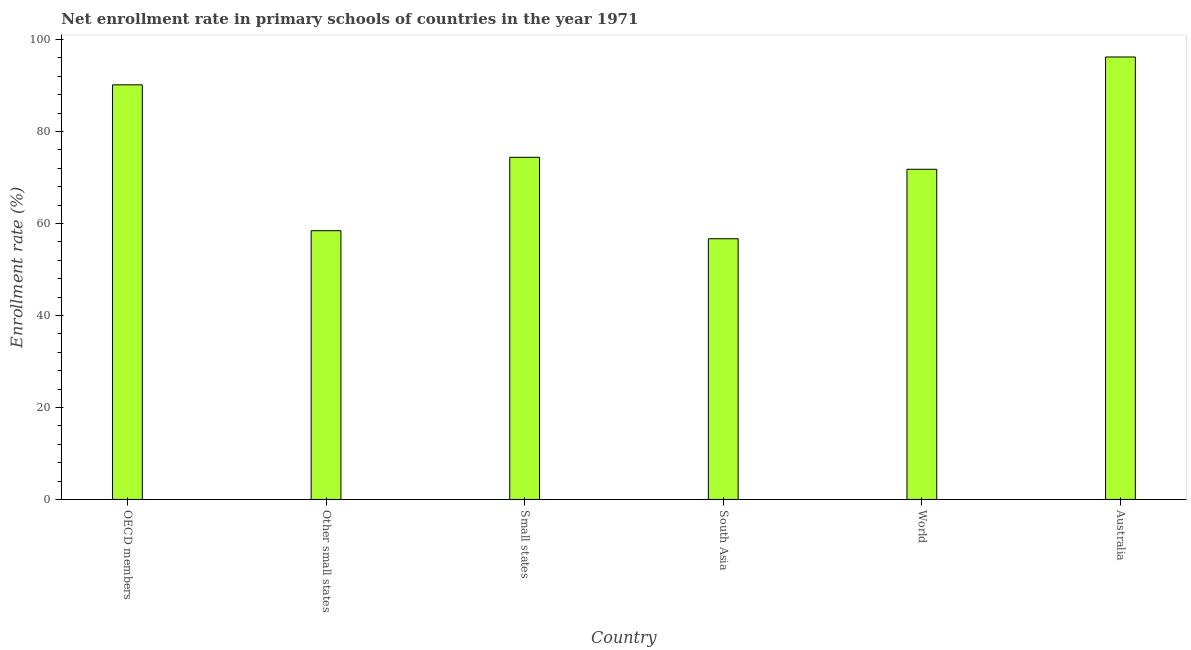Does the graph contain any zero values?
Your answer should be very brief. No. What is the title of the graph?
Ensure brevity in your answer.  Net enrollment rate in primary schools of countries in the year 1971. What is the label or title of the Y-axis?
Provide a succinct answer. Enrollment rate (%). What is the net enrollment rate in primary schools in World?
Ensure brevity in your answer.  71.79. Across all countries, what is the maximum net enrollment rate in primary schools?
Offer a terse response. 96.2. Across all countries, what is the minimum net enrollment rate in primary schools?
Keep it short and to the point. 56.69. In which country was the net enrollment rate in primary schools maximum?
Ensure brevity in your answer.  Australia. In which country was the net enrollment rate in primary schools minimum?
Give a very brief answer. South Asia. What is the sum of the net enrollment rate in primary schools?
Your response must be concise. 447.65. What is the difference between the net enrollment rate in primary schools in South Asia and World?
Your answer should be compact. -15.1. What is the average net enrollment rate in primary schools per country?
Provide a short and direct response. 74.61. What is the median net enrollment rate in primary schools?
Provide a succinct answer. 73.09. In how many countries, is the net enrollment rate in primary schools greater than 20 %?
Offer a terse response. 6. What is the ratio of the net enrollment rate in primary schools in OECD members to that in South Asia?
Ensure brevity in your answer.  1.59. What is the difference between the highest and the second highest net enrollment rate in primary schools?
Your answer should be very brief. 6.05. Is the sum of the net enrollment rate in primary schools in OECD members and World greater than the maximum net enrollment rate in primary schools across all countries?
Provide a short and direct response. Yes. What is the difference between the highest and the lowest net enrollment rate in primary schools?
Offer a very short reply. 39.51. How many bars are there?
Your response must be concise. 6. Are all the bars in the graph horizontal?
Keep it short and to the point. No. What is the Enrollment rate (%) in OECD members?
Provide a succinct answer. 90.15. What is the Enrollment rate (%) of Other small states?
Ensure brevity in your answer.  58.44. What is the Enrollment rate (%) of Small states?
Your answer should be very brief. 74.39. What is the Enrollment rate (%) in South Asia?
Offer a terse response. 56.69. What is the Enrollment rate (%) in World?
Provide a succinct answer. 71.79. What is the Enrollment rate (%) in Australia?
Make the answer very short. 96.2. What is the difference between the Enrollment rate (%) in OECD members and Other small states?
Provide a succinct answer. 31.71. What is the difference between the Enrollment rate (%) in OECD members and Small states?
Your answer should be compact. 15.76. What is the difference between the Enrollment rate (%) in OECD members and South Asia?
Provide a succinct answer. 33.46. What is the difference between the Enrollment rate (%) in OECD members and World?
Ensure brevity in your answer.  18.36. What is the difference between the Enrollment rate (%) in OECD members and Australia?
Your answer should be compact. -6.05. What is the difference between the Enrollment rate (%) in Other small states and Small states?
Offer a terse response. -15.95. What is the difference between the Enrollment rate (%) in Other small states and South Asia?
Provide a short and direct response. 1.75. What is the difference between the Enrollment rate (%) in Other small states and World?
Make the answer very short. -13.35. What is the difference between the Enrollment rate (%) in Other small states and Australia?
Ensure brevity in your answer.  -37.76. What is the difference between the Enrollment rate (%) in Small states and South Asia?
Make the answer very short. 17.7. What is the difference between the Enrollment rate (%) in Small states and World?
Your response must be concise. 2.6. What is the difference between the Enrollment rate (%) in Small states and Australia?
Offer a very short reply. -21.81. What is the difference between the Enrollment rate (%) in South Asia and World?
Make the answer very short. -15.1. What is the difference between the Enrollment rate (%) in South Asia and Australia?
Your answer should be very brief. -39.51. What is the difference between the Enrollment rate (%) in World and Australia?
Your answer should be compact. -24.41. What is the ratio of the Enrollment rate (%) in OECD members to that in Other small states?
Provide a succinct answer. 1.54. What is the ratio of the Enrollment rate (%) in OECD members to that in Small states?
Make the answer very short. 1.21. What is the ratio of the Enrollment rate (%) in OECD members to that in South Asia?
Make the answer very short. 1.59. What is the ratio of the Enrollment rate (%) in OECD members to that in World?
Offer a very short reply. 1.26. What is the ratio of the Enrollment rate (%) in OECD members to that in Australia?
Provide a short and direct response. 0.94. What is the ratio of the Enrollment rate (%) in Other small states to that in Small states?
Make the answer very short. 0.79. What is the ratio of the Enrollment rate (%) in Other small states to that in South Asia?
Offer a very short reply. 1.03. What is the ratio of the Enrollment rate (%) in Other small states to that in World?
Offer a terse response. 0.81. What is the ratio of the Enrollment rate (%) in Other small states to that in Australia?
Your answer should be compact. 0.61. What is the ratio of the Enrollment rate (%) in Small states to that in South Asia?
Make the answer very short. 1.31. What is the ratio of the Enrollment rate (%) in Small states to that in World?
Your answer should be compact. 1.04. What is the ratio of the Enrollment rate (%) in Small states to that in Australia?
Offer a very short reply. 0.77. What is the ratio of the Enrollment rate (%) in South Asia to that in World?
Give a very brief answer. 0.79. What is the ratio of the Enrollment rate (%) in South Asia to that in Australia?
Make the answer very short. 0.59. What is the ratio of the Enrollment rate (%) in World to that in Australia?
Your answer should be very brief. 0.75. 